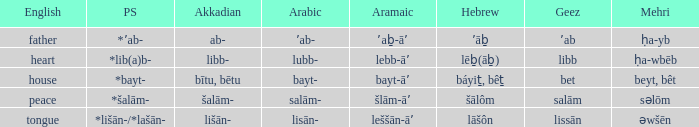If in arabic it is salām-, what is it in proto-semitic? *šalām-. 